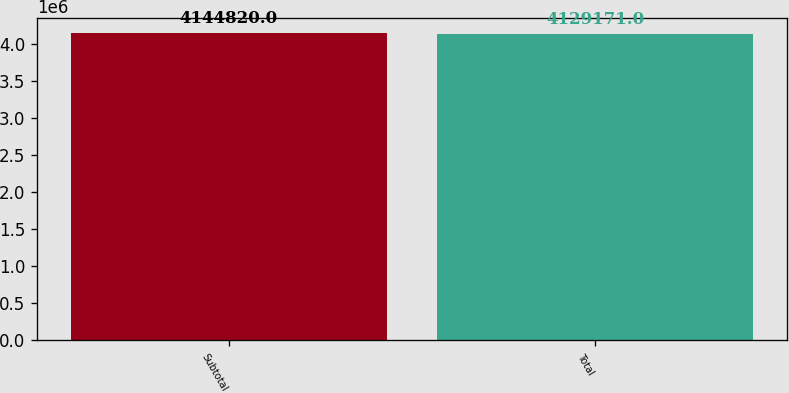Convert chart. <chart><loc_0><loc_0><loc_500><loc_500><bar_chart><fcel>Subtotal<fcel>Total<nl><fcel>4.14482e+06<fcel>4.12917e+06<nl></chart> 